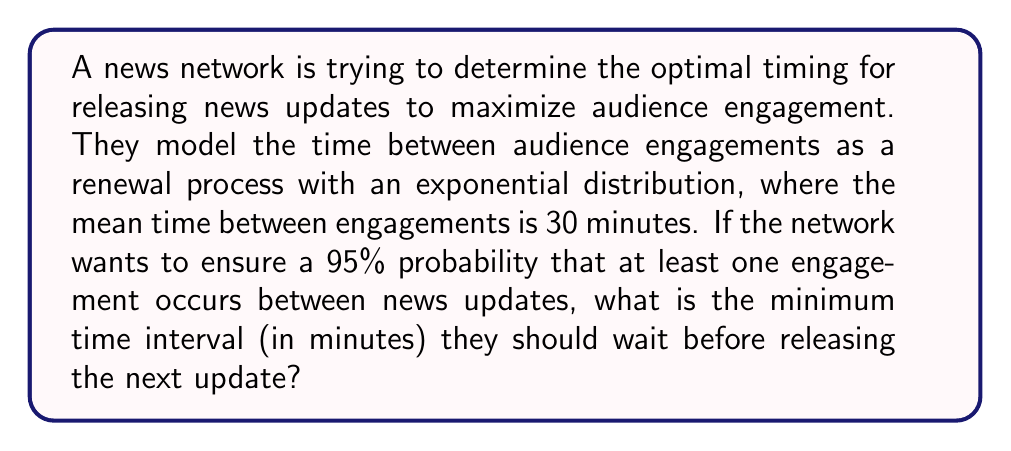Could you help me with this problem? Let's approach this step-by-step:

1) We are dealing with a renewal process where the time between events (audience engagements) follows an exponential distribution.

2) The mean time between engagements is given as 30 minutes. For an exponential distribution, this is equal to $\frac{1}{\lambda}$, where $\lambda$ is the rate parameter. So:

   $\frac{1}{\lambda} = 30$
   $\lambda = \frac{1}{30}$

3) We want to find the time $t$ such that the probability of at least one engagement occurring within this time is 0.95 (95%).

4) The probability of no events occurring in time $t$ for an exponential distribution is given by:

   $P(\text{no events in } t) = e^{-\lambda t}$

5) Therefore, the probability of at least one event occurring is:

   $P(\text{at least one event in } t) = 1 - e^{-\lambda t}$

6) We want this probability to be 0.95:

   $1 - e^{-\lambda t} = 0.95$

7) Solving for $t$:

   $e^{-\lambda t} = 0.05$
   $-\lambda t = \ln(0.05)$
   $t = -\frac{\ln(0.05)}{\lambda} = -30 \ln(0.05)$

8) Calculating this value:

   $t \approx 89.96$ minutes

9) Rounding up to the nearest minute (as we need the minimum time that ensures the 95% probability):

   $t = 90$ minutes
Answer: 90 minutes 